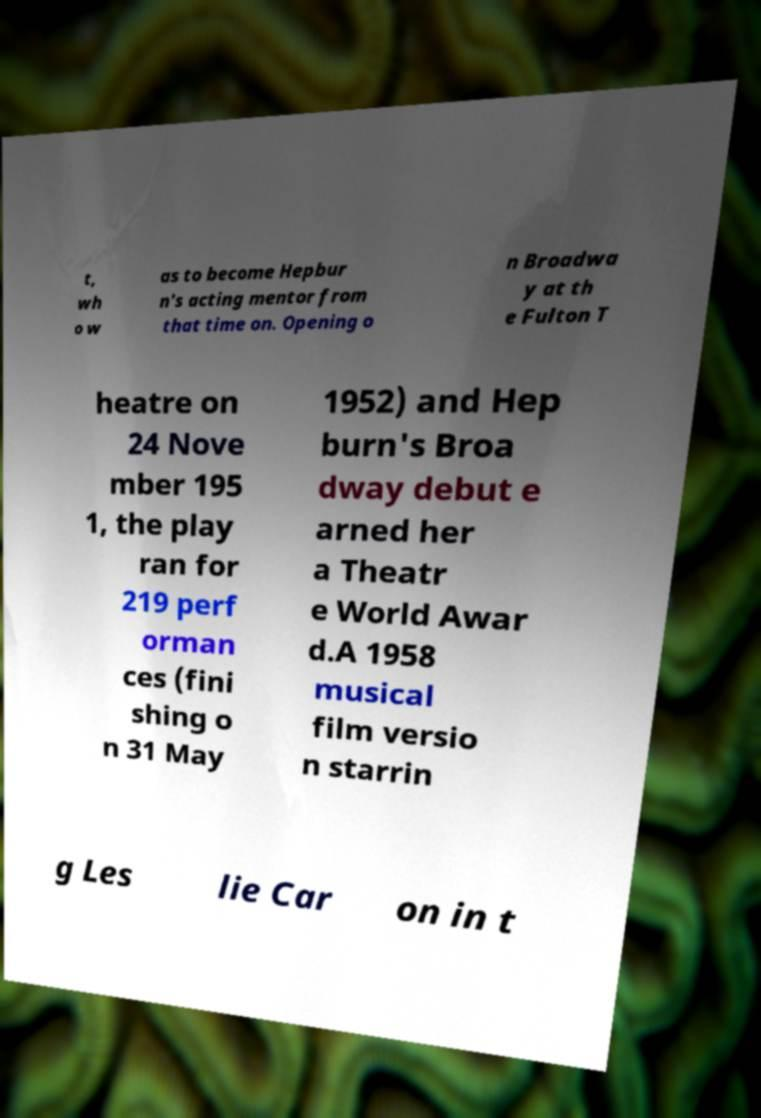Please read and relay the text visible in this image. What does it say? t, wh o w as to become Hepbur n's acting mentor from that time on. Opening o n Broadwa y at th e Fulton T heatre on 24 Nove mber 195 1, the play ran for 219 perf orman ces (fini shing o n 31 May 1952) and Hep burn's Broa dway debut e arned her a Theatr e World Awar d.A 1958 musical film versio n starrin g Les lie Car on in t 